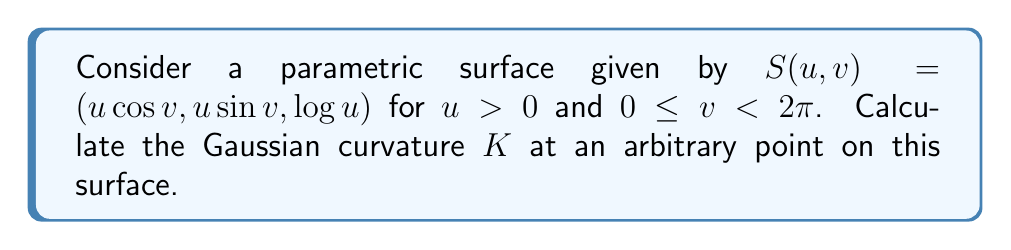Could you help me with this problem? To calculate the Gaussian curvature, we'll follow these steps:

1) First, we need to compute the partial derivatives:
   $S_u = (\cos v, \sin v, \frac{1}{u})$
   $S_v = (-u\sin v, u\cos v, 0)$

2) Now, we calculate the coefficients of the first fundamental form:
   $E = S_u \cdot S_u = \cos^2 v + \sin^2 v + \frac{1}{u^2} = 1 + \frac{1}{u^2}$
   $F = S_u \cdot S_v = 0$
   $G = S_v \cdot S_v = u^2\sin^2 v + u^2\cos^2 v = u^2$

3) Next, we compute the second partial derivatives:
   $S_{uu} = (0, 0, -\frac{1}{u^2})$
   $S_{uv} = (-\sin v, \cos v, 0)$
   $S_{vv} = (-u\cos v, -u\sin v, 0)$

4) We calculate the normal vector:
   $N = \frac{S_u \times S_v}{|S_u \times S_v|} = \frac{(-\cos v, -\sin v, u)}{\sqrt{u^2 + 1}}$

5) Now we compute the coefficients of the second fundamental form:
   $L = S_{uu} \cdot N = \frac{1}{u\sqrt{u^2 + 1}}$
   $M = S_{uv} \cdot N = 0$
   $N = S_{vv} \cdot N = \frac{u^2}{\sqrt{u^2 + 1}}$

6) The Gaussian curvature is given by:
   $K = \frac{LN - M^2}{EG - F^2}$

7) Substituting our calculated values:
   $K = \frac{\frac{1}{u\sqrt{u^2 + 1}} \cdot \frac{u^2}{\sqrt{u^2 + 1}} - 0^2}{(1 + \frac{1}{u^2}) \cdot u^2 - 0^2}$

8) Simplifying:
   $K = \frac{u}{(u^2 + 1)^{\frac{3}{2}}}$

This is the Gaussian curvature at any point $(u,v)$ on the surface.
Answer: $K = \frac{u}{(u^2 + 1)^{\frac{3}{2}}}$ 